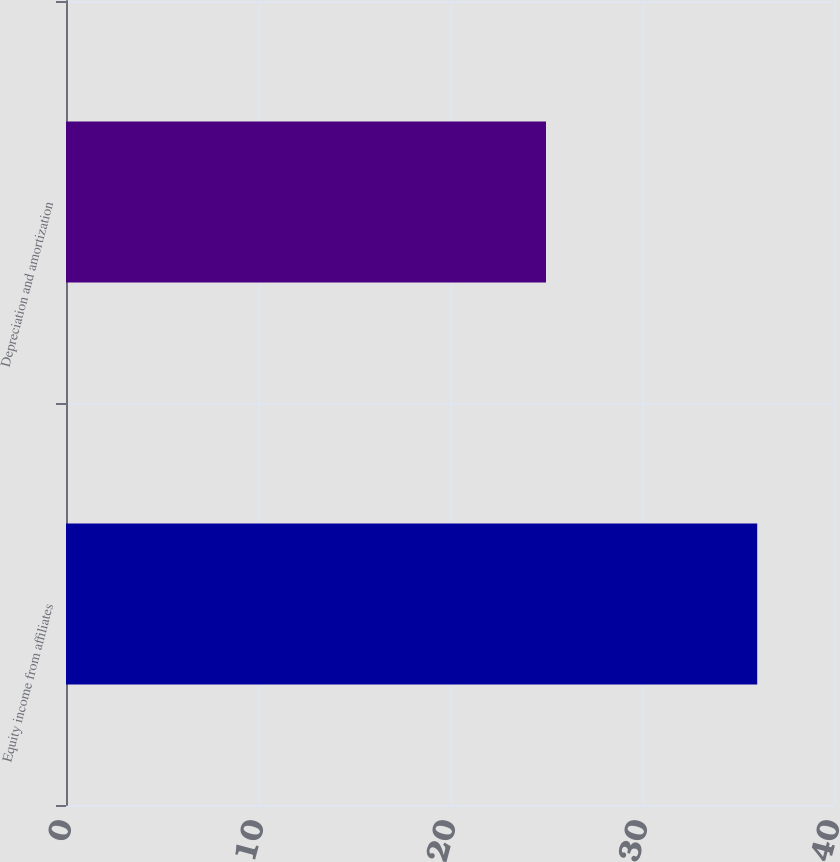<chart> <loc_0><loc_0><loc_500><loc_500><bar_chart><fcel>Equity income from affiliates<fcel>Depreciation and amortization<nl><fcel>36<fcel>25<nl></chart> 